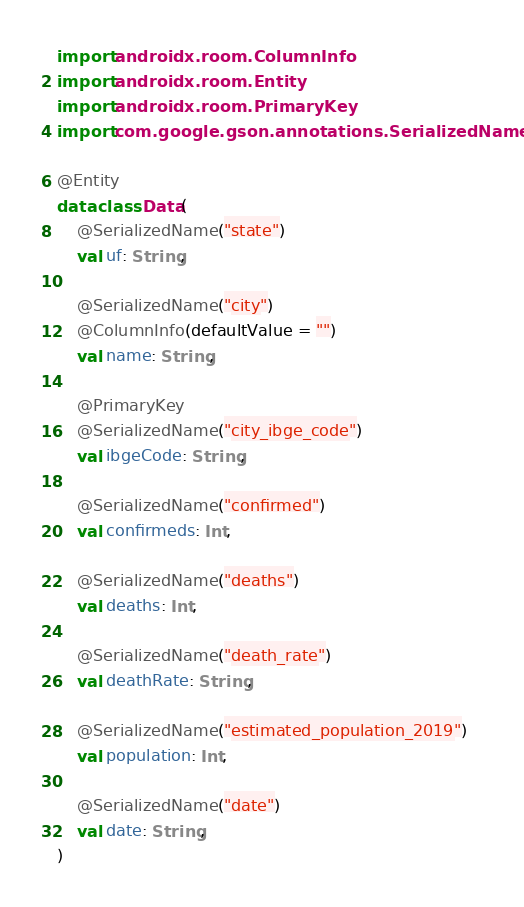Convert code to text. <code><loc_0><loc_0><loc_500><loc_500><_Kotlin_>import androidx.room.ColumnInfo
import androidx.room.Entity
import androidx.room.PrimaryKey
import com.google.gson.annotations.SerializedName

@Entity
data class Data(
    @SerializedName("state")
    val uf: String,

    @SerializedName("city")
    @ColumnInfo(defaultValue = "")
    val name: String,

    @PrimaryKey
    @SerializedName("city_ibge_code")
    val ibgeCode: String,

    @SerializedName("confirmed")
    val confirmeds: Int,

    @SerializedName("deaths")
    val deaths: Int,

    @SerializedName("death_rate")
    val deathRate: String,

    @SerializedName("estimated_population_2019")
    val population: Int,

    @SerializedName("date")
    val date: String,
)</code> 